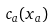Convert formula to latex. <formula><loc_0><loc_0><loc_500><loc_500>c _ { a } ( x _ { a } )</formula> 